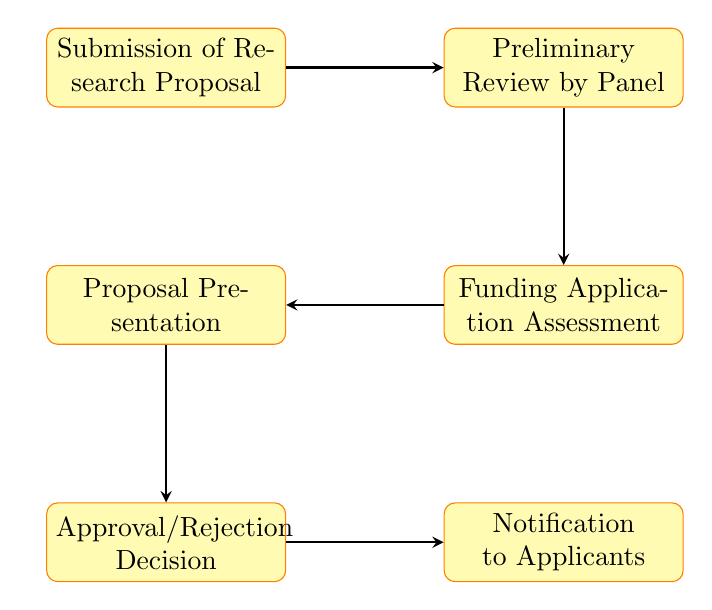What is the first step in the funding approval process? The diagram starts with the "Submission of Research Proposal" node, indicating that this is the initial step of the process.
Answer: Submission of Research Proposal How many steps are involved in the process? Counting the nodes in the diagram, there are six distinct steps from the submission of proposals to the notification to applicants.
Answer: Six What comes after the "Preliminary Review by Panel"? According to the diagram, the step that follows the "Preliminary Review by Panel" is the "Funding Application Assessment."
Answer: Funding Application Assessment What is the last step in the funding approval process? The final node in the flow chart indicates that the last step is "Notification to Applicants," which concludes the process.
Answer: Notification to Applicants Which step involves researchers addressing queries? The diagram shows that the "Proposal Presentation" step is where researchers provide insights and address queries related to their projects.
Answer: Proposal Presentation What are the two steps immediately preceding the "Approval/Rejection Decision"? The steps leading up to the "Approval/Rejection Decision" are "Proposal Presentation" and "Funding Application Assessment," indicating the process flow immediately before that decision point.
Answer: Proposal Presentation and Funding Application Assessment In which step is the proposal's feasibility assessed? The "Preliminary Review by Panel" step is where experts conduct the initial review to evaluate both relevance and feasibility of proposals.
Answer: Preliminary Review by Panel How are applicants informed about the outcome of their proposals? The diagram illustrates that the outcome is communicated to applicants during the "Notification to Applicants" step.
Answer: Notification to Applicants What is the purpose of the "Funding Application Assessment" step? This step is aimed at a detailed evaluation of funding applications, focusing on aspects like budget feasibility and resource allocation.
Answer: Detailed assessment What type of document is submitted in the first step? The very first node refers to "Research Proposal," indicating that it is the type of document submitted at the beginning of the process.
Answer: Research Proposal 